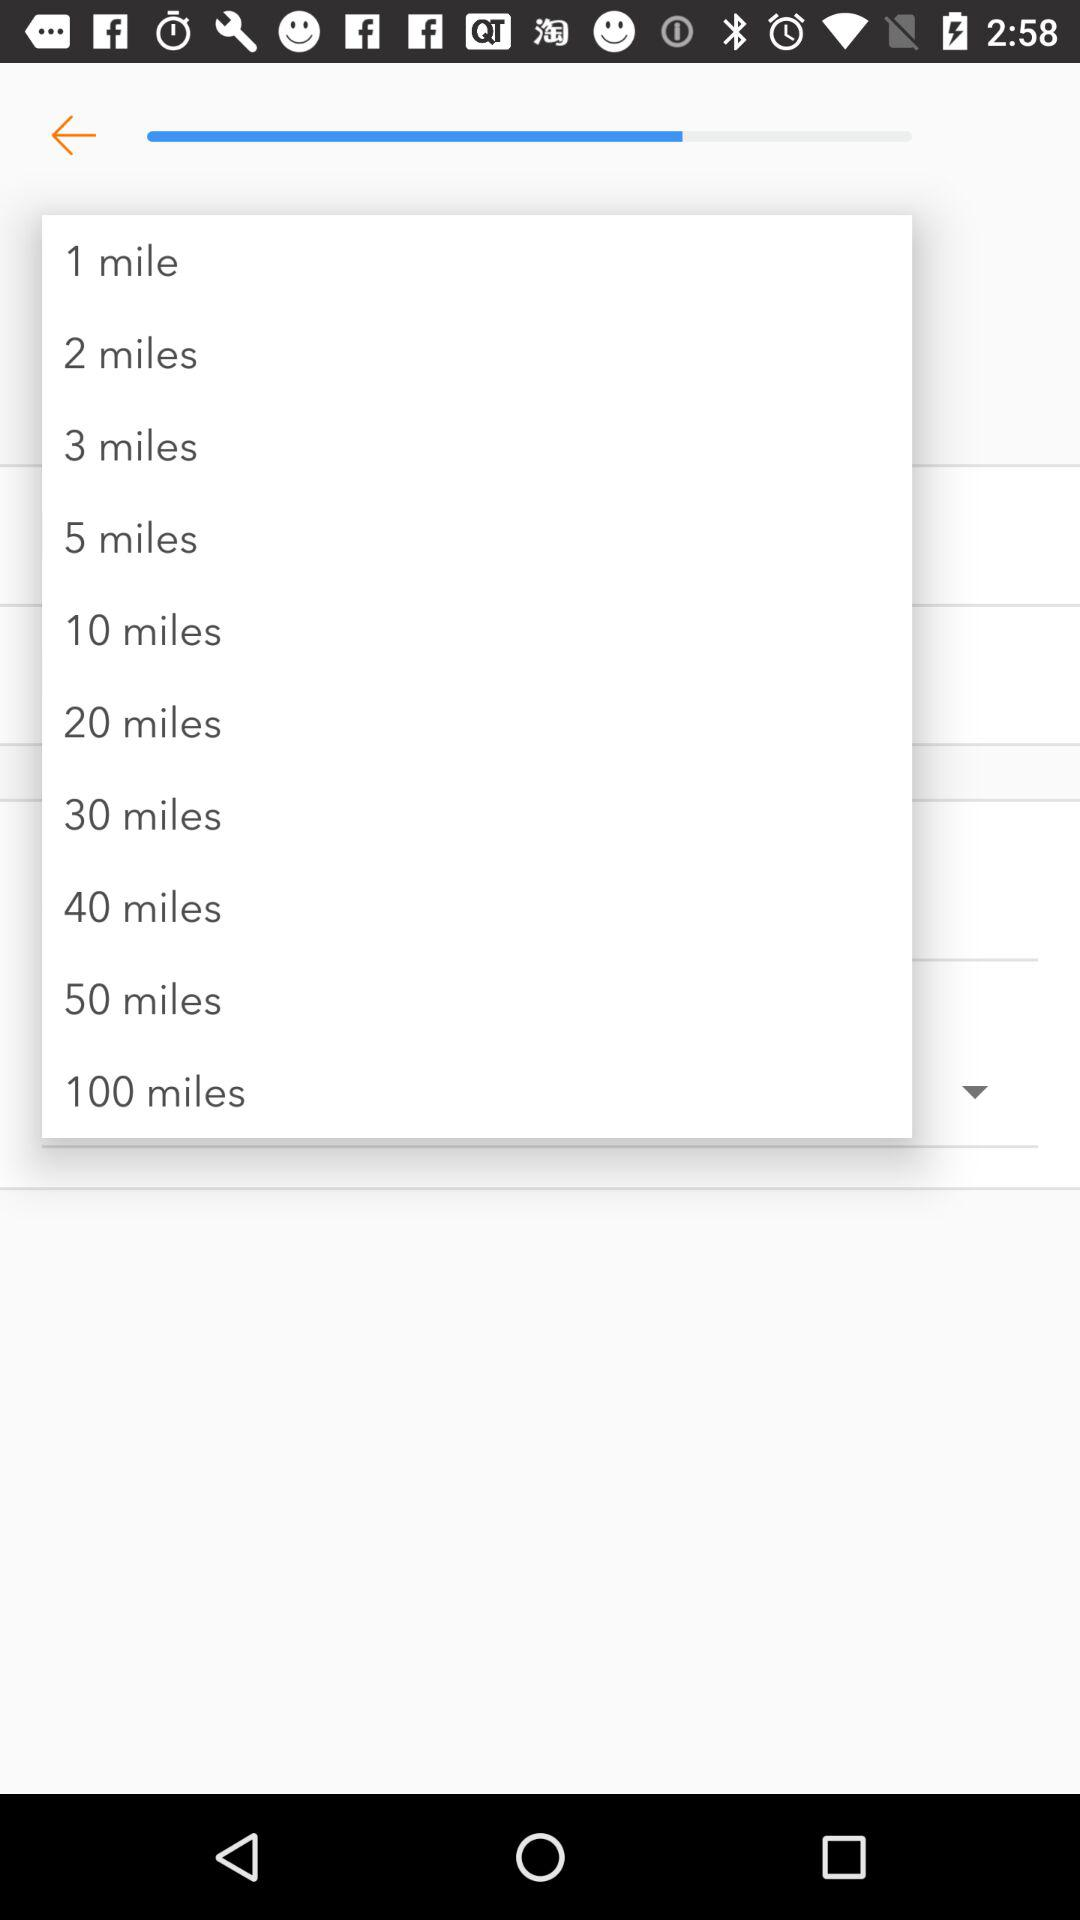How many more miles are there between the 50 mile and 100 mile options?
Answer the question using a single word or phrase. 50 